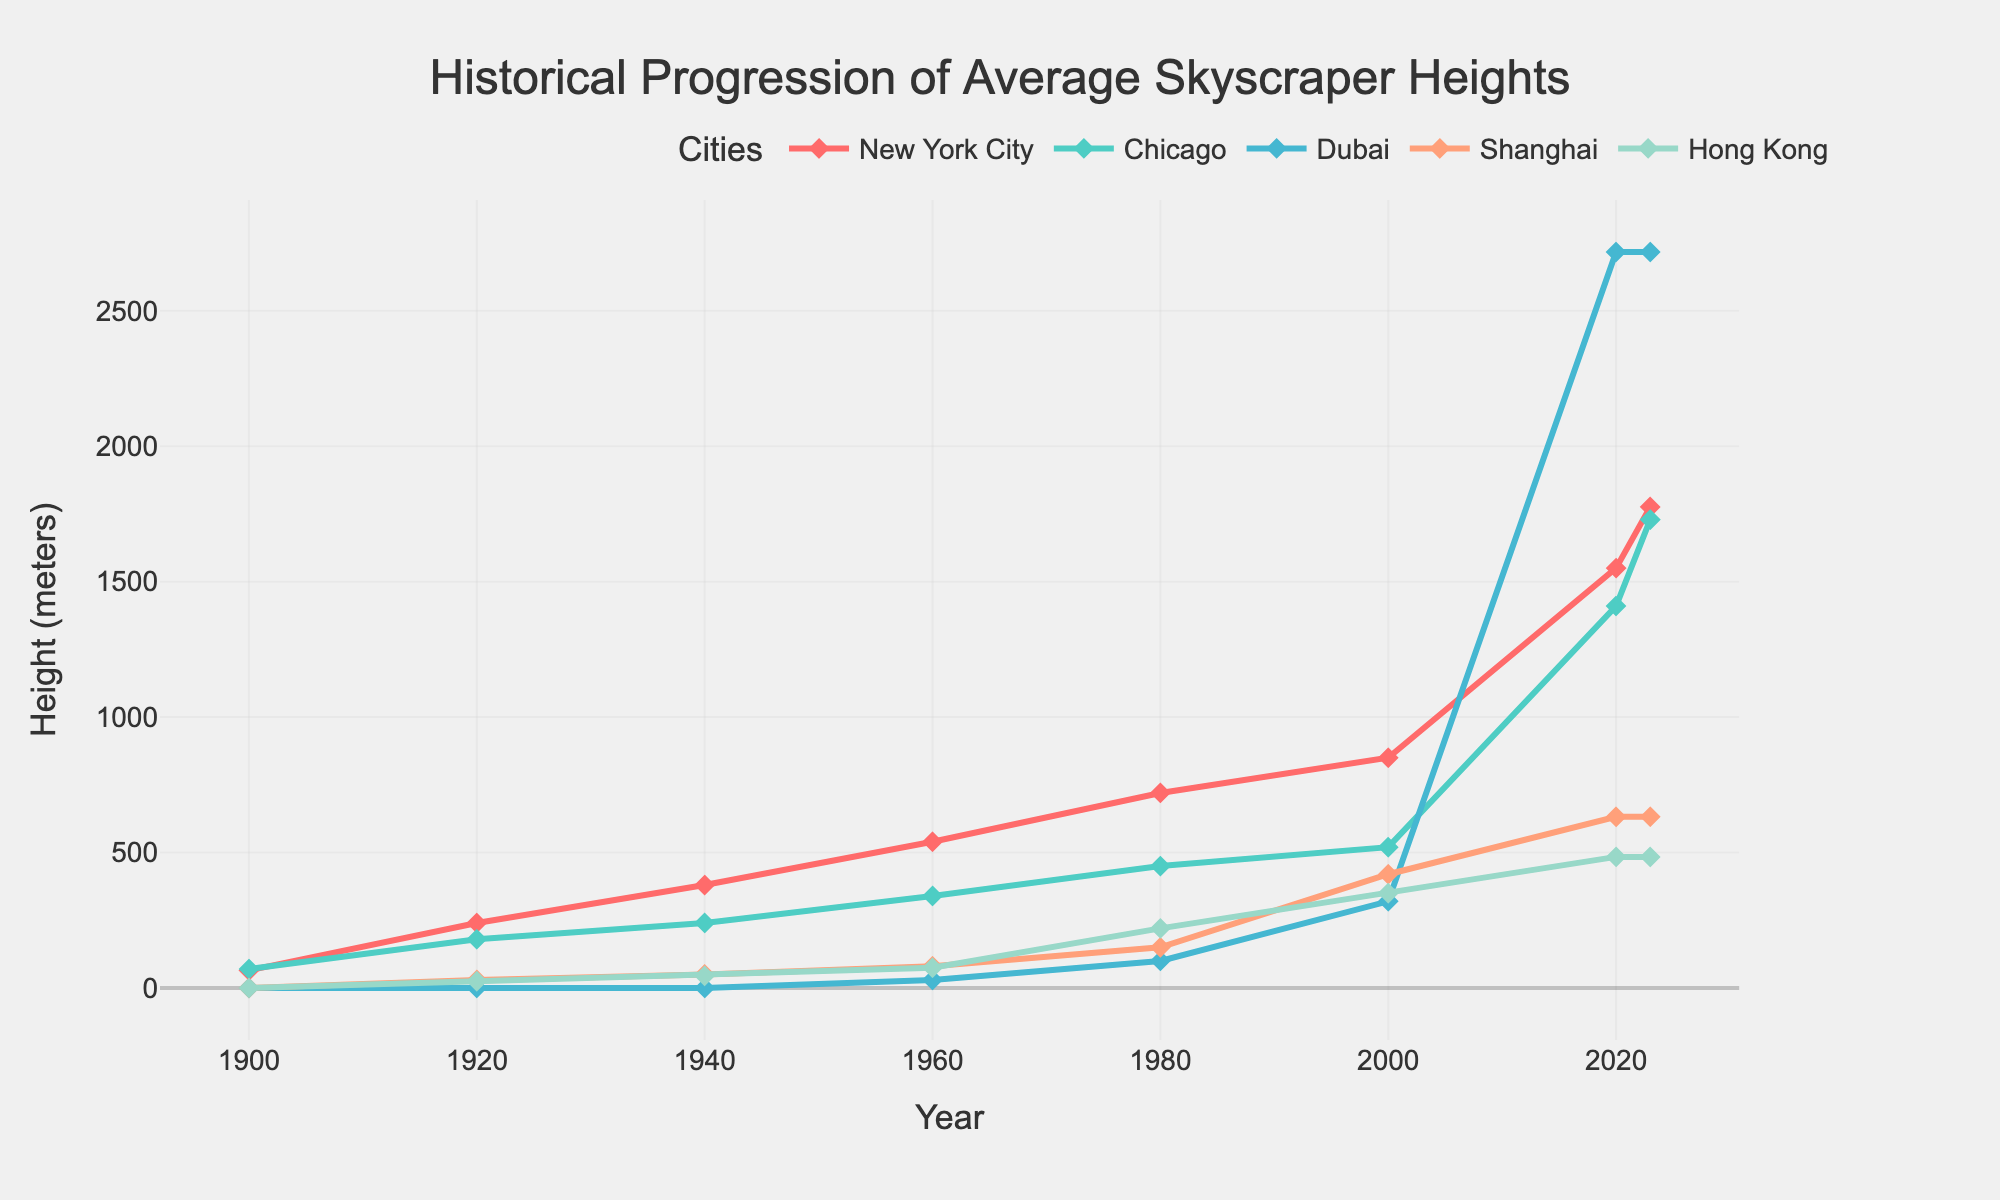What's the tallest average skyscraper height in 2020? To find the tallest average skyscraper height in 2020, look for the highest value among all the cities in the year 2020 on the chart. New York City has a height of 1550 meters, which is the tallest among the given cities.
Answer: 1550 meters In which year did Dubai see its first significant increase in average skyscraper height? Check the line for Dubai and find the first noticeable rise in height. It happens between 1980 and 2000, where the height increases from 100 meters to 320 meters.
Answer: Between 1980 and 2000 By how much did the average skyscraper height in Chicago increase from 2000 to 2023? To find the increase, subtract the height in 2000 from the height in 2023 for Chicago. The heights are 1729 meters in 2023 and 520 meters in 2000. So, 1729 - 520 = 1209 meters.
Answer: 1209 meters Which city saw the most significant increase in average skyscraper height between 2000 and 2020? Compare the changes in height for each city between 2000 and 2020. Dubai's height increased the most, from 320 meters in 2000 to 2717 meters in 2020, an increase of 2397 meters.
Answer: Dubai What colors represent New York City and Hong Kong on the chart? New York City is represented by the first color and Hong Kong by the fifth color in the sequence. From the description, New York City is red and Hong Kong is in a different color, which is assumed to be the fifth in the list: light green.
Answer: Red for New York City and Light Green for Hong Kong How does the skyscraper height trend in Shanghai compare to Hong Kong between 1980 and 2020? Observe the trend lines for Shanghai and Hong Kong. Both show an upward trend, but Hong Kong's increase is less steep compared to Shanghai. Shanghai rises from 150 meters in 2000 to 632 meters in 2020, while Hong Kong increases from 350 meters in 2000 to 484 meters in 2020.
Answer: Shanghai's trend shows a steeper increase compared to Hong Kong What's the average skyscraper height in New York City in the years shown? To calculate the average, sum up all heights for New York City and divide by the number of years. Heights: 65+240+380+540+720+850+1550+1776 = 6121 meters. Number of data points: 8. So, 6121 / 8 ≈ 765.13 meters.
Answer: 765.13 meters Which city had the highest average skyscraper height in 1960? Look at all the height values for the year 1960 and identify the tallest. New York City had the highest with 540 meters.
Answer: New York City What is the difference in average skyscraper height between New York City and Shanghai in 2023? Subtract the height of Shanghai from that of New York City in 2023. New York City is 1776 meters and Shanghai is 632 meters. So, 1776 - 632 = 1144 meters.
Answer: 1144 meters 